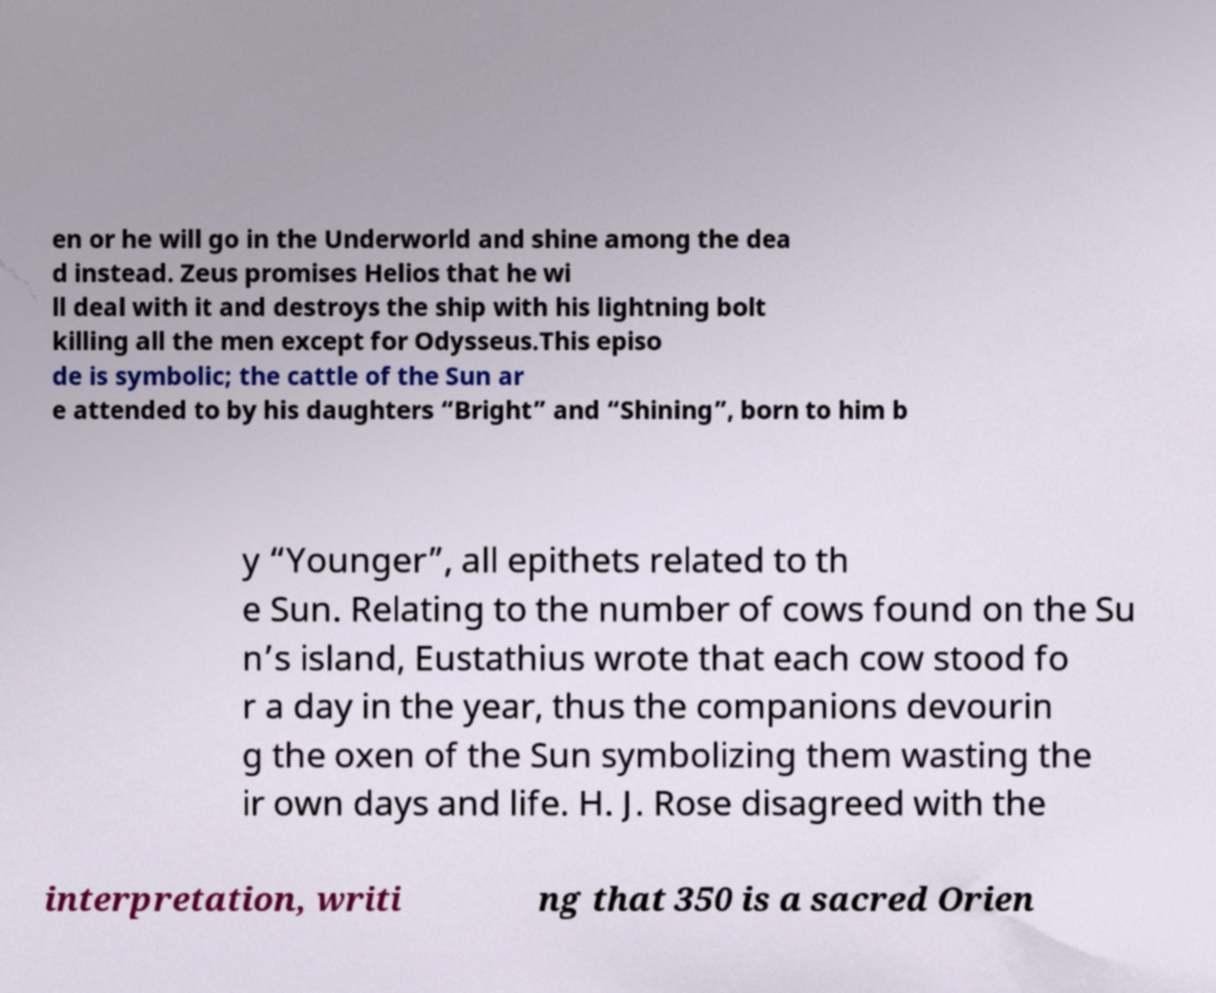Could you assist in decoding the text presented in this image and type it out clearly? en or he will go in the Underworld and shine among the dea d instead. Zeus promises Helios that he wi ll deal with it and destroys the ship with his lightning bolt killing all the men except for Odysseus.This episo de is symbolic; the cattle of the Sun ar e attended to by his daughters “Bright” and “Shining”, born to him b y “Younger”, all epithets related to th e Sun. Relating to the number of cows found on the Su n’s island, Eustathius wrote that each cow stood fo r a day in the year, thus the companions devourin g the oxen of the Sun symbolizing them wasting the ir own days and life. H. J. Rose disagreed with the interpretation, writi ng that 350 is a sacred Orien 